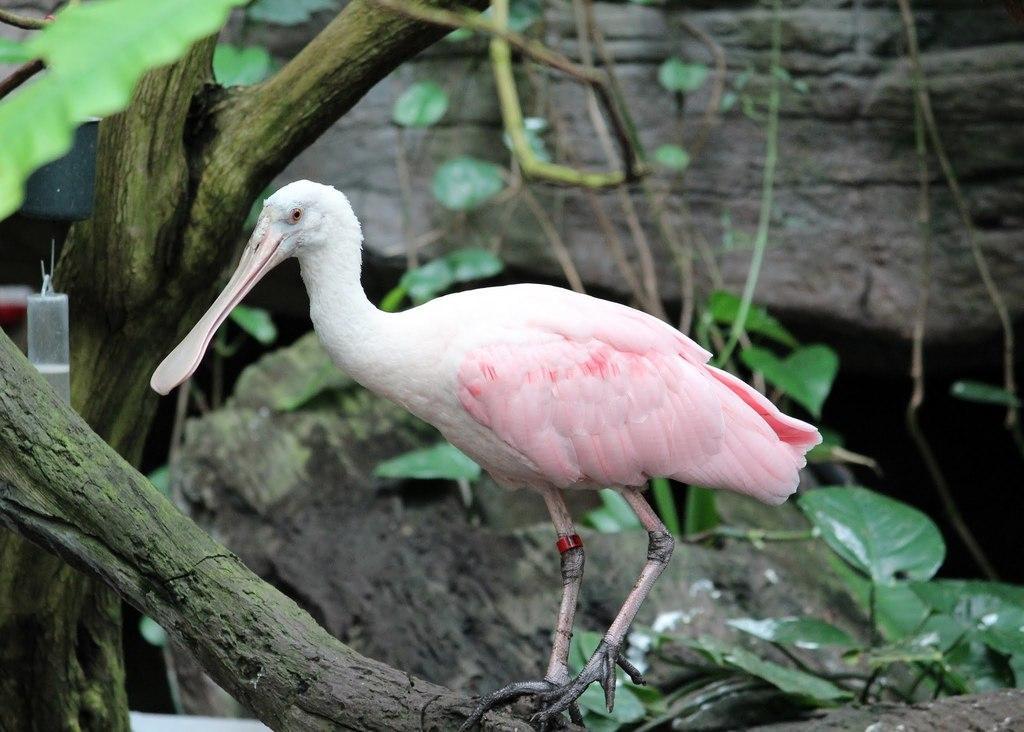Can you describe this image briefly? In this image, in the middle, we can see a bird standing on the wooden trump. On the right side, we can see some plants with green leaves. On the left side, we can also see a bottle, leaves. In the background, we can see some rocks. 